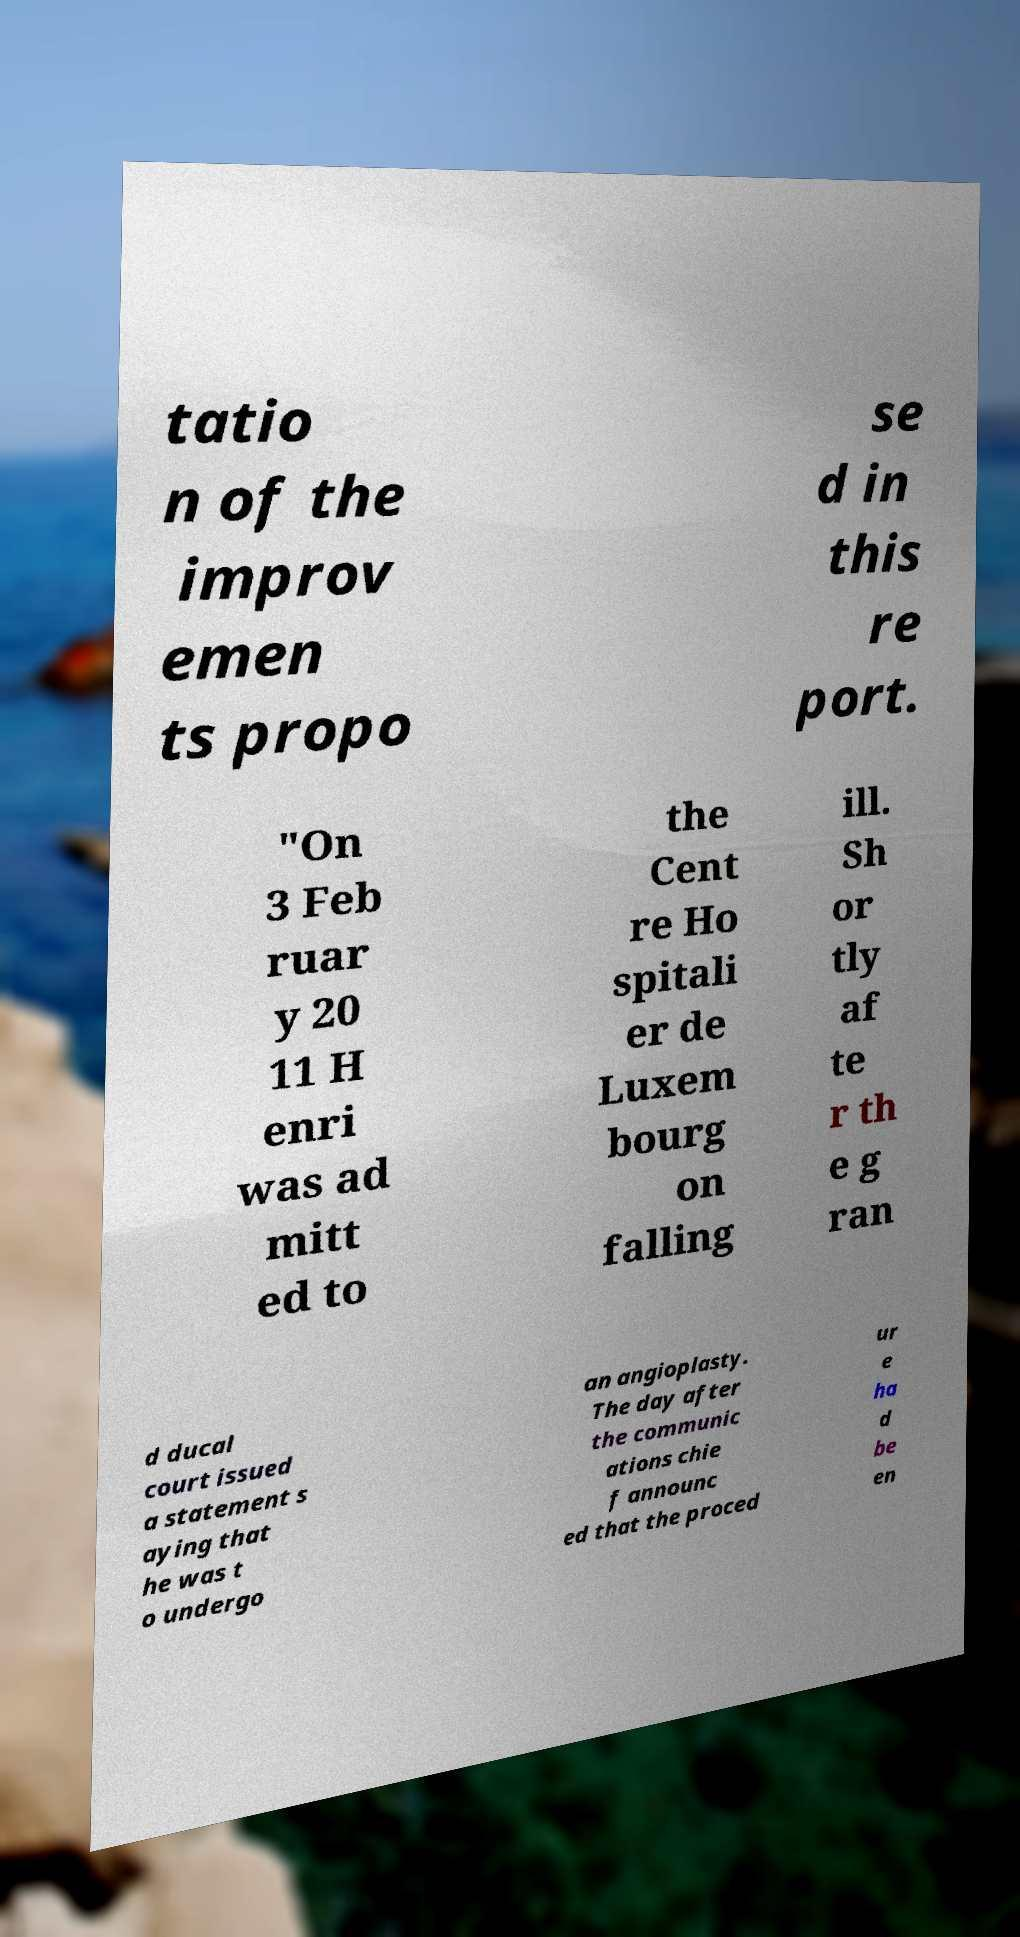Could you extract and type out the text from this image? tatio n of the improv emen ts propo se d in this re port. "On 3 Feb ruar y 20 11 H enri was ad mitt ed to the Cent re Ho spitali er de Luxem bourg on falling ill. Sh or tly af te r th e g ran d ducal court issued a statement s aying that he was t o undergo an angioplasty. The day after the communic ations chie f announc ed that the proced ur e ha d be en 